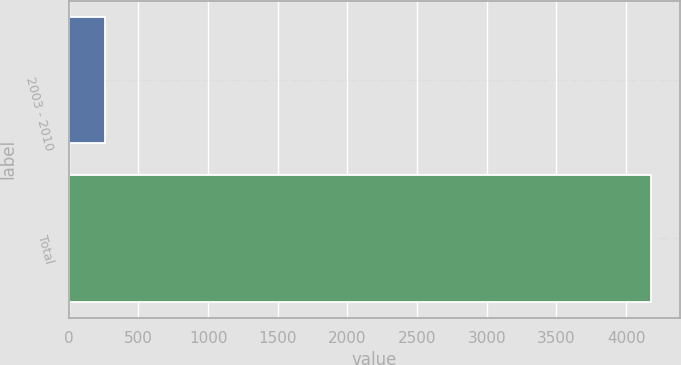<chart> <loc_0><loc_0><loc_500><loc_500><bar_chart><fcel>2003 - 2010<fcel>Total<nl><fcel>258<fcel>4179<nl></chart> 